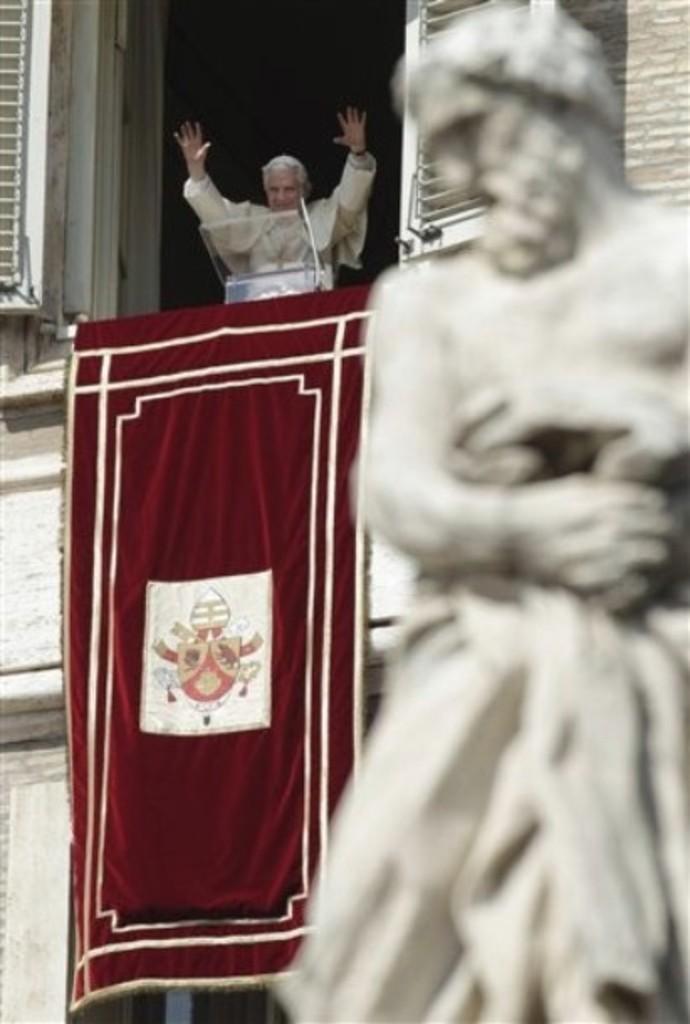Describe this image in one or two sentences. In this image I can see a statue which is white in color. I can see a building and a red colored cloth to the building. I can see a person standing inside the building. 